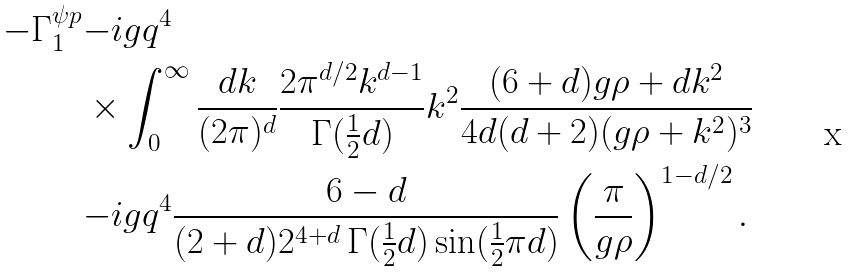Convert formula to latex. <formula><loc_0><loc_0><loc_500><loc_500>- \Gamma ^ { \psi p } _ { 1 } & { - } i g q ^ { 4 } \\ & \times \int _ { 0 } ^ { \infty } \frac { d k } { ( 2 \pi ) ^ { d } } \frac { 2 \pi ^ { d / 2 } k ^ { d - 1 } } { \Gamma ( \frac { 1 } { 2 } d ) } k ^ { 2 } \frac { ( 6 + d ) g \rho + d k ^ { 2 } } { 4 d ( d + 2 ) ( g \rho + k ^ { 2 } ) ^ { 3 } } \\ & { - } i g q ^ { 4 } \frac { 6 - d } { ( 2 + d ) 2 ^ { 4 + d } \, \Gamma ( \frac { 1 } { 2 } d ) \sin ( \frac { 1 } { 2 } \pi d ) } \left ( \frac { \pi } { g \rho } \right ) ^ { 1 - d / 2 } .</formula> 